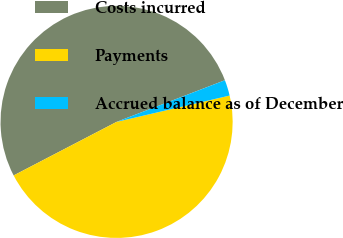<chart> <loc_0><loc_0><loc_500><loc_500><pie_chart><fcel>Costs incurred<fcel>Payments<fcel>Accrued balance as of December<nl><fcel>51.79%<fcel>46.01%<fcel>2.2%<nl></chart> 